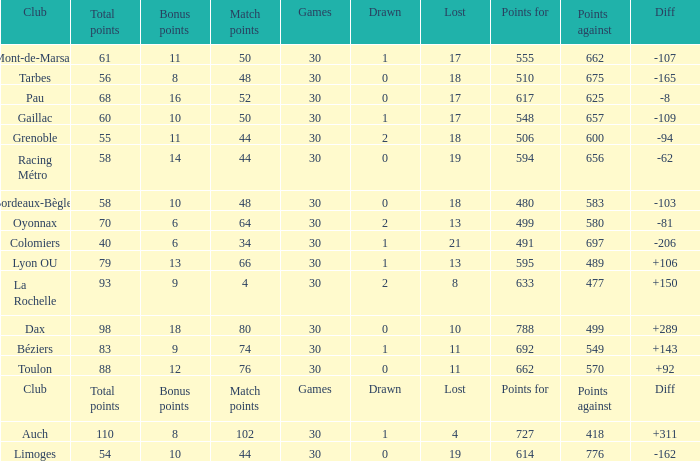What is the value of match points when the points for is 570? 76.0. 